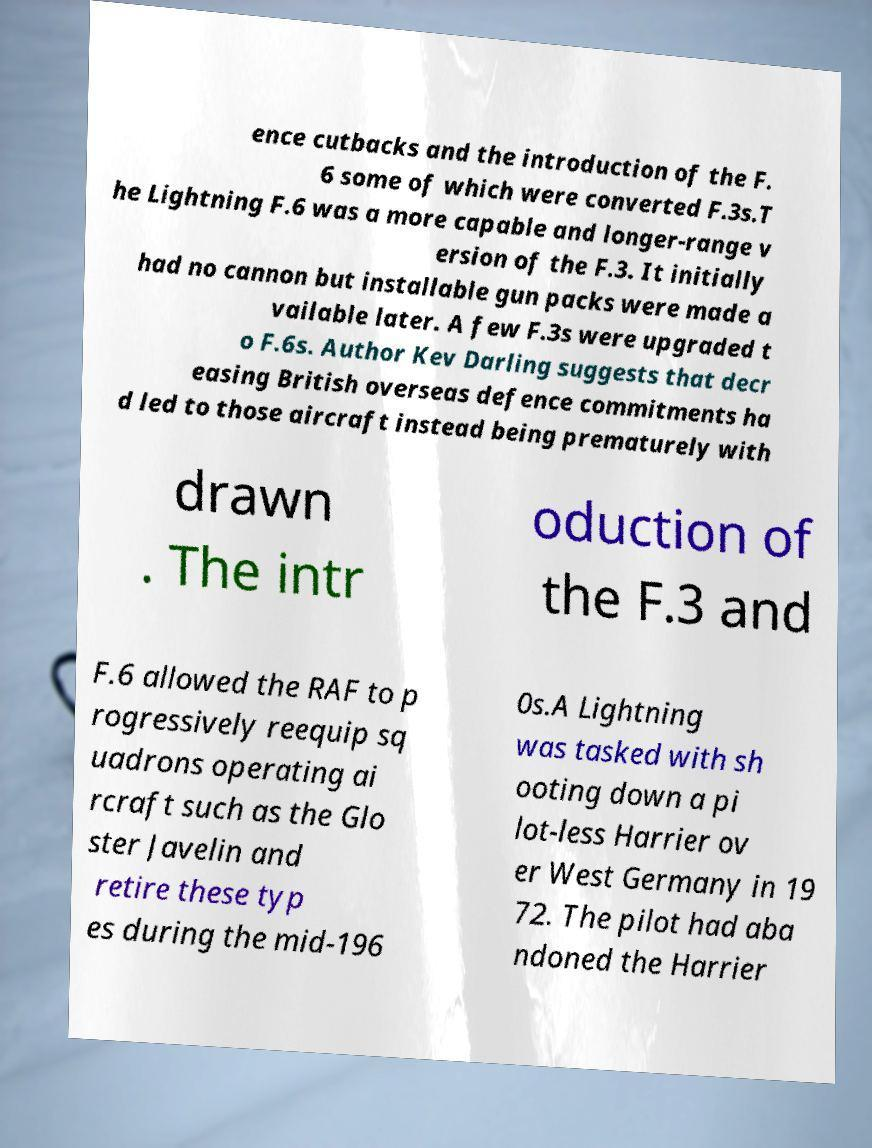Could you extract and type out the text from this image? ence cutbacks and the introduction of the F. 6 some of which were converted F.3s.T he Lightning F.6 was a more capable and longer-range v ersion of the F.3. It initially had no cannon but installable gun packs were made a vailable later. A few F.3s were upgraded t o F.6s. Author Kev Darling suggests that decr easing British overseas defence commitments ha d led to those aircraft instead being prematurely with drawn . The intr oduction of the F.3 and F.6 allowed the RAF to p rogressively reequip sq uadrons operating ai rcraft such as the Glo ster Javelin and retire these typ es during the mid-196 0s.A Lightning was tasked with sh ooting down a pi lot-less Harrier ov er West Germany in 19 72. The pilot had aba ndoned the Harrier 